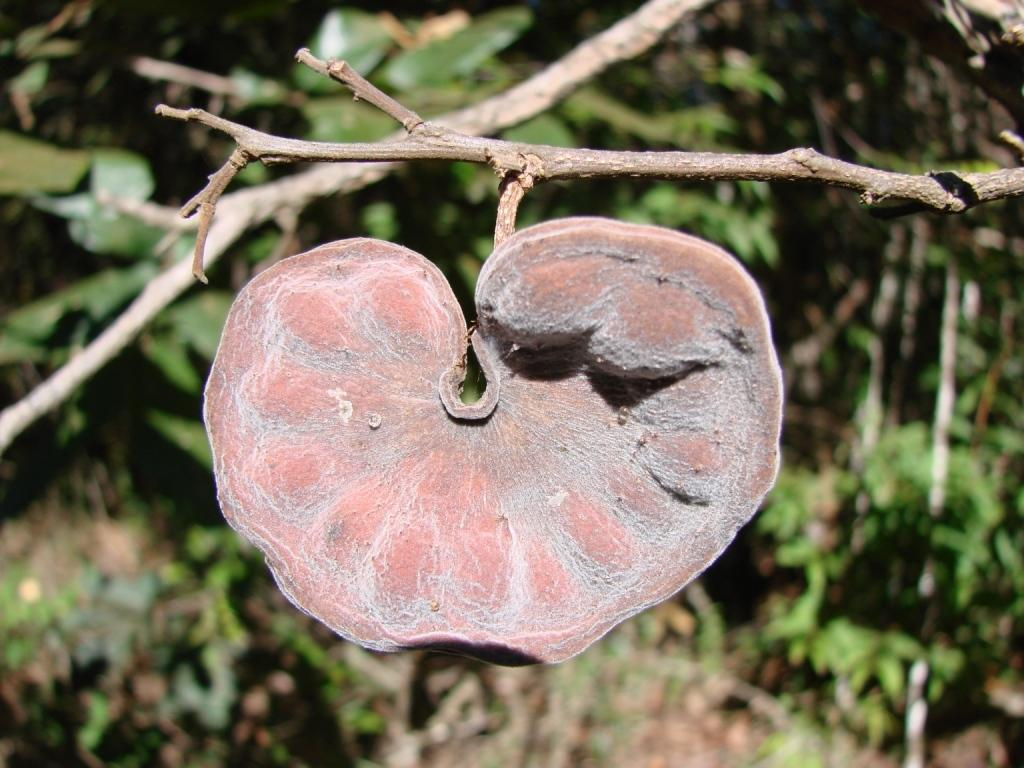What can be found in the image that resembles plant stems? There are stems in the image. What is the brown object located in the front of the image? There is a brown color thing in the front of the image. What type of natural scenery can be seen in the background of the image? There are trees in the background of the image. How would you describe the clarity of the background in the image? The background of the image is slightly blurry. Is there any smoke coming from the brown object in the image? There is no smoke present in the image. Can you tell me how many berries are on the stems in the image? There is no mention of berries in the provided facts, so we cannot determine the number of berries on the stems. 